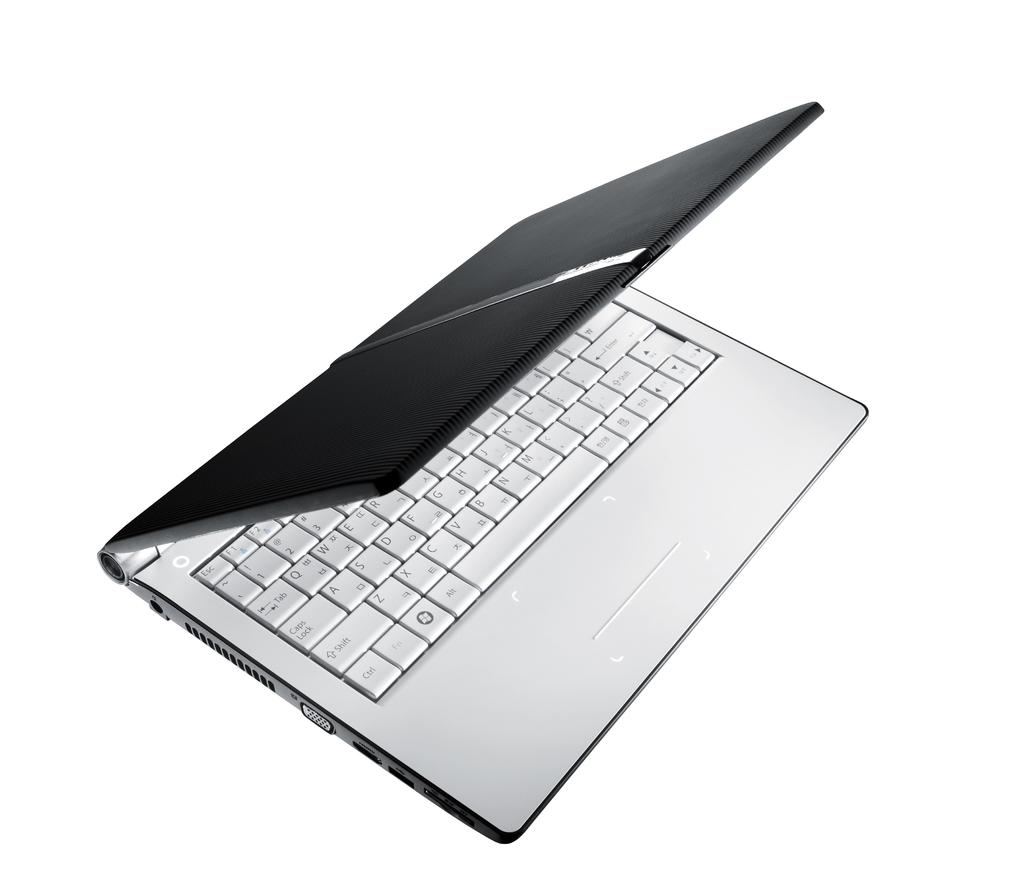<image>
Describe the image concisely. A lap top is open, the left lower key is the control key. 